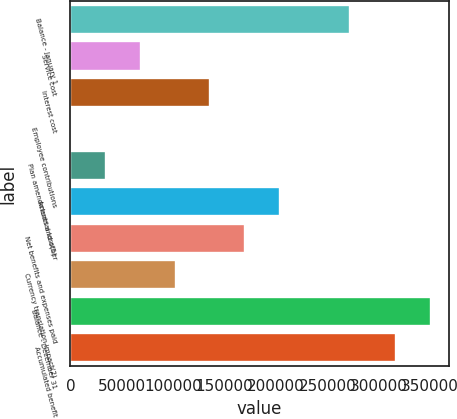<chart> <loc_0><loc_0><loc_500><loc_500><bar_chart><fcel>Balance - January 1<fcel>Service cost<fcel>Interest cost<fcel>Employee contributions<fcel>Plan amendments and other<fcel>Actuarial loss(1)<fcel>Net benefits and expenses paid<fcel>Currency translation impact(2)<fcel>Balance - December 31<fcel>Accumulated benefit<nl><fcel>271638<fcel>68237.6<fcel>136265<fcel>210<fcel>34223.8<fcel>204293<fcel>170279<fcel>102251<fcel>350681<fcel>316667<nl></chart> 